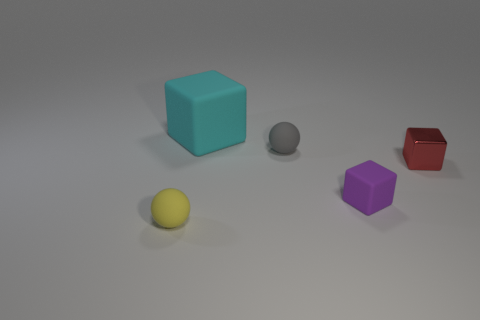There is a red metallic object that is the same shape as the purple matte thing; what is its size?
Your answer should be compact. Small. Are there more large cyan rubber things that are on the left side of the tiny yellow rubber sphere than small purple matte cubes to the right of the small purple rubber object?
Provide a succinct answer. No. There is a small object that is both right of the large cyan thing and to the left of the purple block; what material is it made of?
Your answer should be compact. Rubber. What is the color of the large matte thing that is the same shape as the tiny purple thing?
Keep it short and to the point. Cyan. What is the size of the gray matte ball?
Offer a very short reply. Small. There is a small sphere that is behind the rubber thing left of the cyan cube; what color is it?
Provide a short and direct response. Gray. How many tiny things are both on the right side of the big rubber object and in front of the small purple matte thing?
Your answer should be compact. 0. Are there more large brown balls than small purple cubes?
Your answer should be very brief. No. What material is the large thing?
Your response must be concise. Rubber. There is a small rubber ball that is in front of the small purple cube; how many small red metal things are left of it?
Your answer should be compact. 0. 